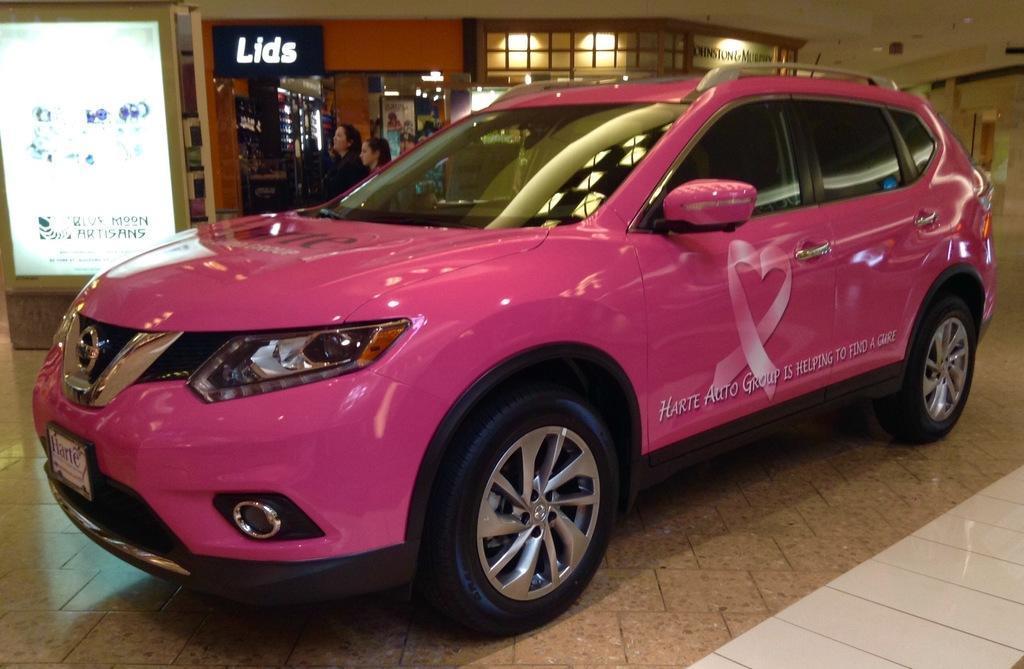How would you summarize this image in a sentence or two? This image consists of a car in pink color. At the bottom, there is a floor. In the background, there is a board. And there are many people,. 